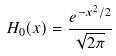Convert formula to latex. <formula><loc_0><loc_0><loc_500><loc_500>H _ { 0 } ( x ) = \frac { e ^ { - x ^ { 2 } / 2 } } { \sqrt { 2 \pi } }</formula> 